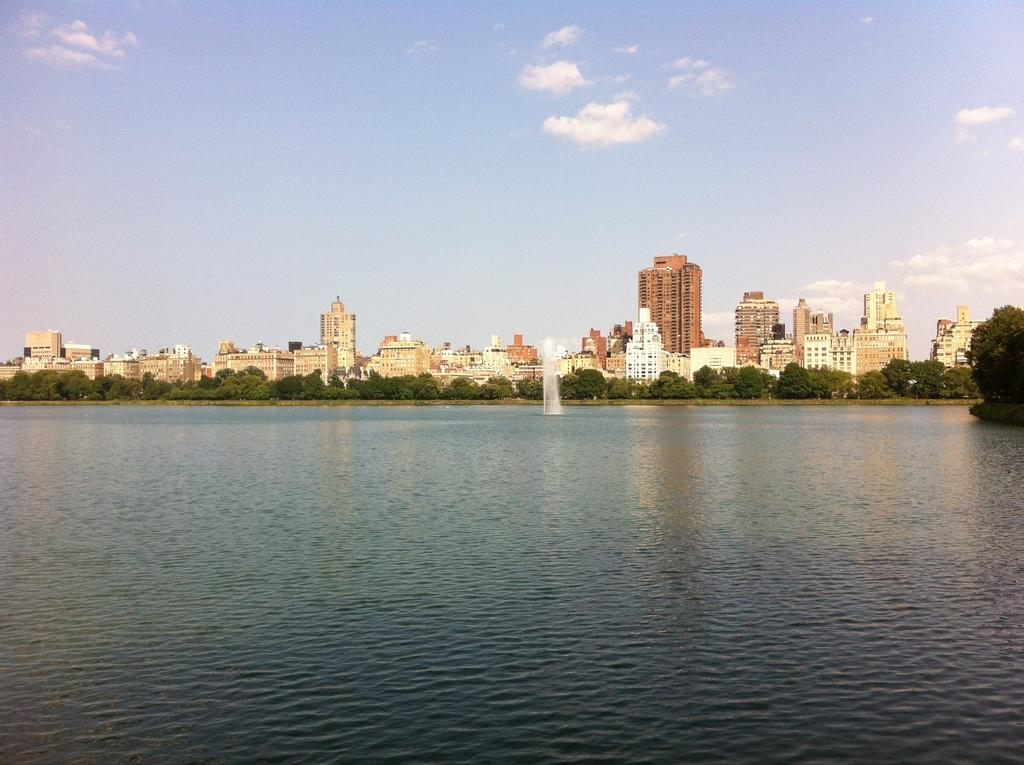What type of structures can be seen in the image? There are buildings in the image. What other elements are present in the image besides buildings? There are plants and a water fountain in the image. What can be seen in the background of the image? The sky is visible in the background of the image. How many quince are being used to decorate the water fountain in the image? There are no quince present in the image, as it features buildings, plants, and a water fountain, but no quince. What type of dirt can be seen on the ground near the water fountain in the image? There is no dirt visible in the image; the ground appears to be paved or covered with some other material. 